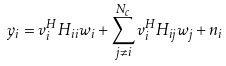<formula> <loc_0><loc_0><loc_500><loc_500>y _ { i } = v _ { i } ^ { H } H _ { i i } w _ { i } + \sum _ { j \neq i } ^ { N _ { c } } v _ { i } ^ { H } H _ { i j } w _ { j } + n _ { i }</formula> 